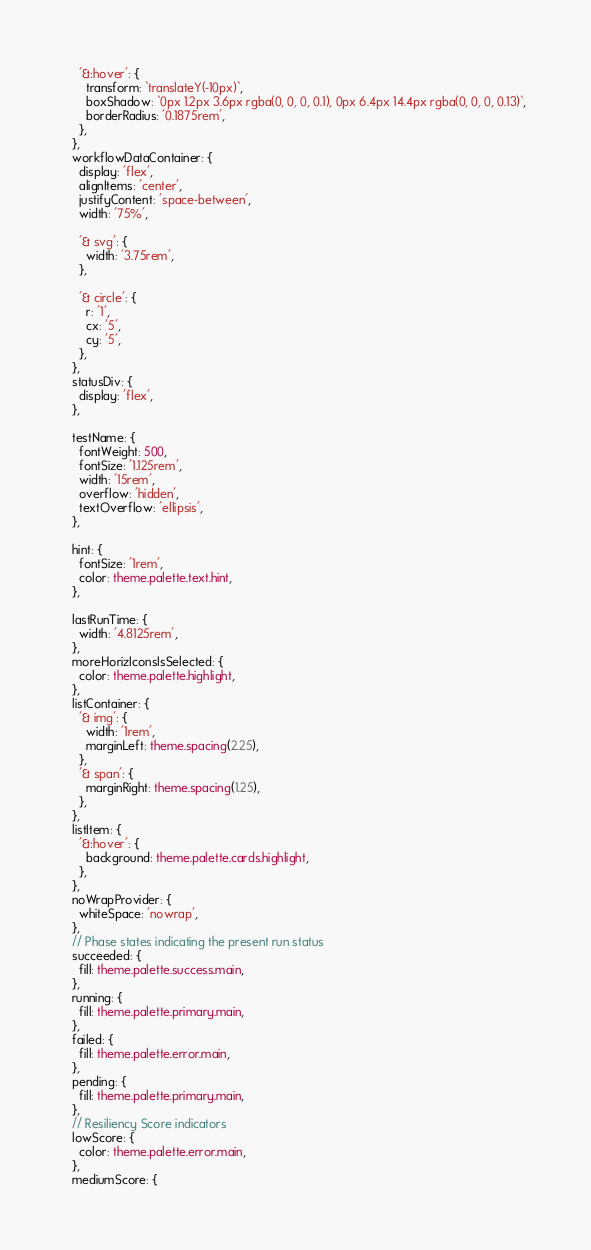<code> <loc_0><loc_0><loc_500><loc_500><_TypeScript_>    '&:hover': {
      transform: `translateY(-10px)`,
      boxShadow: `0px 1.2px 3.6px rgba(0, 0, 0, 0.1), 0px 6.4px 14.4px rgba(0, 0, 0, 0.13)`,
      borderRadius: '0.1875rem',
    },
  },
  workflowDataContainer: {
    display: 'flex',
    alignItems: 'center',
    justifyContent: 'space-between',
    width: '75%',

    '& svg': {
      width: '3.75rem',
    },

    '& circle': {
      r: '1',
      cx: '5',
      cy: '5',
    },
  },
  statusDiv: {
    display: 'flex',
  },

  testName: {
    fontWeight: 500,
    fontSize: '1.125rem',
    width: '15rem',
    overflow: 'hidden',
    textOverflow: 'ellipsis',
  },

  hint: {
    fontSize: '1rem',
    color: theme.palette.text.hint,
  },

  lastRunTime: {
    width: '4.8125rem',
  },
  moreHorizIconsIsSelected: {
    color: theme.palette.highlight,
  },
  listContainer: {
    '& img': {
      width: '1rem',
      marginLeft: theme.spacing(2.25),
    },
    '& span': {
      marginRight: theme.spacing(1.25),
    },
  },
  listItem: {
    '&:hover': {
      background: theme.palette.cards.highlight,
    },
  },
  noWrapProvider: {
    whiteSpace: 'nowrap',
  },
  // Phase states indicating the present run status
  succeeded: {
    fill: theme.palette.success.main,
  },
  running: {
    fill: theme.palette.primary.main,
  },
  failed: {
    fill: theme.palette.error.main,
  },
  pending: {
    fill: theme.palette.primary.main,
  },
  // Resiliency Score indicators
  lowScore: {
    color: theme.palette.error.main,
  },
  mediumScore: {</code> 